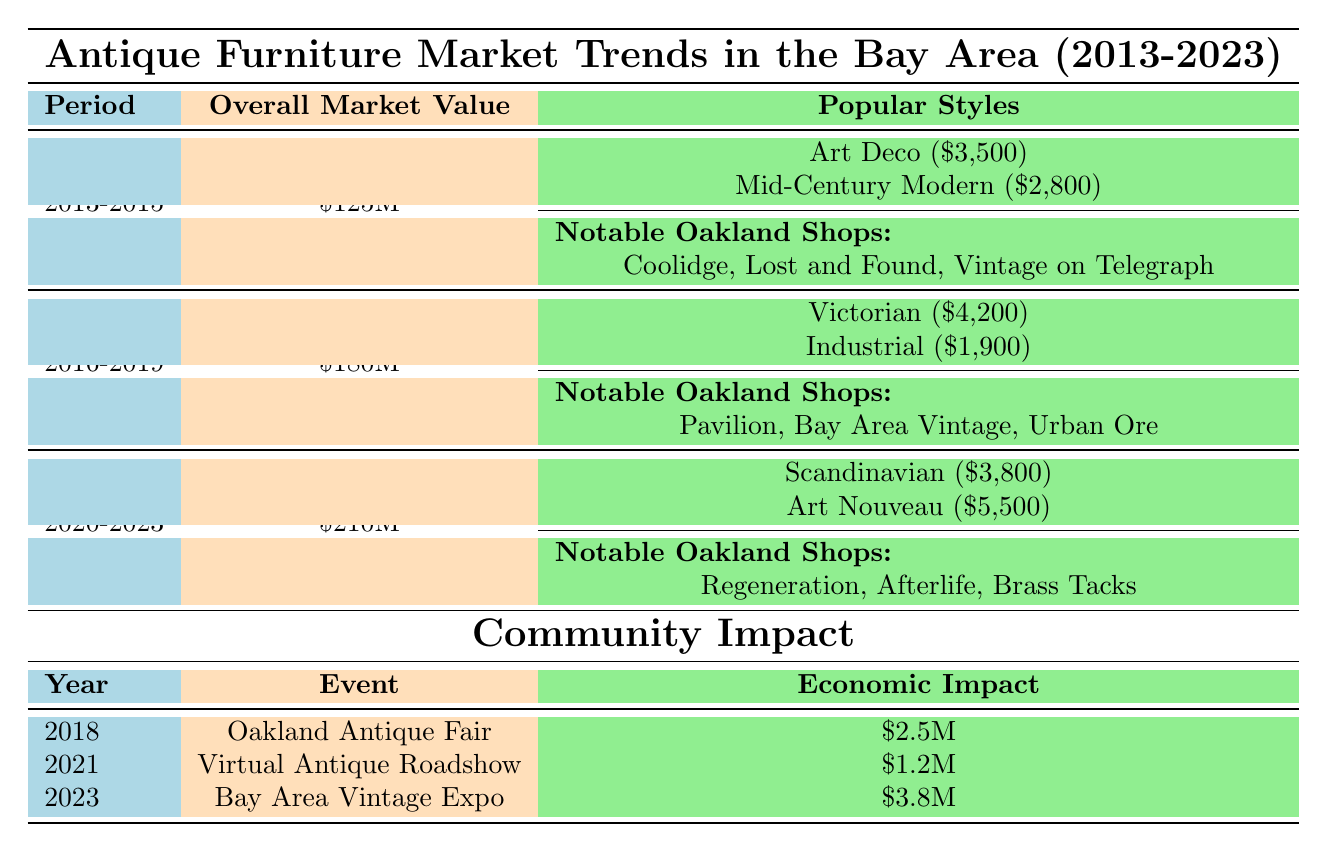What was the overall market value of antique furniture in the Bay Area between 2016 and 2019? In the table under the period 2016-2019, the overall market value is explicitly stated as $180M.
Answer: $180M Which antique style had the highest average price in the period 2020-2023? The styles listed for 2020-2023 include Scandinavian ($3,800) and Art Nouveau ($5,500). Art Nouveau has the highest average price among these.
Answer: Art Nouveau How much did the Oakland Antique Fair contribute to the economy in 2018? The table specifies that the economic impact of the Oakland Antique Fair in 2018 was $2.5M.
Answer: $2.5M How many notable antique shops are listed for the period 2013-2015? For the period 2013-2015, three notable antique shops are mentioned: Coolidge Antiques, Lost and Found Antiques, and Vintage on Telegraph.
Answer: 3 Which period experienced the greatest increase in overall market value? Comparing values: 2013-2015 ($125M), 2016-2019 ($180M) shows an increase of $55M; 2016-2019 to 2020-2023 ($210M) shows an increase of $30M. The greatest increase was from 2013-2015 to 2016-2019.
Answer: 2013-2015 to 2016-2019 What event occurred in 2021 and what was its attendance? The table indicates that in 2021, the event was the Virtual Antique Roadshow with an attendance of 8,000.
Answer: Virtual Antique Roadshow, 8,000 Is it true that the average price of the Victorian style was lower than the Scandinavian style? The table shows Victorian at $4,200 and Scandinavian at $3,800. Since $4,200 is higher than $3,800, the statement is false.
Answer: No What was the total economic impact of the three events listed in the table? The events had economic impacts of $2.5M (2018), $1.2M (2021), and $3.8M (2023). Summing these gives $2.5M + $1.2M + $3.8M = $7.5M.
Answer: $7.5M How many events are documented in the Community Impact section, and what is the average attendance across these events? There are three events listed: Oakland Antique Fair (15,000), Virtual Antique Roadshow (8,000), and Bay Area Vintage Expo (20,000). The average attendance is (15,000 + 8,000 + 20,000) / 3 = 14,333.
Answer: 3 events, average attendance 14,333 Which two styles had the lowest average prices in the listed periods? Between the periods, the styles with the lowest prices are Industrial ($1,900) and Mid-Century Modern ($2,800). Comparing both, Industrial has the lowest price.
Answer: Industrial and Mid-Century Modern 